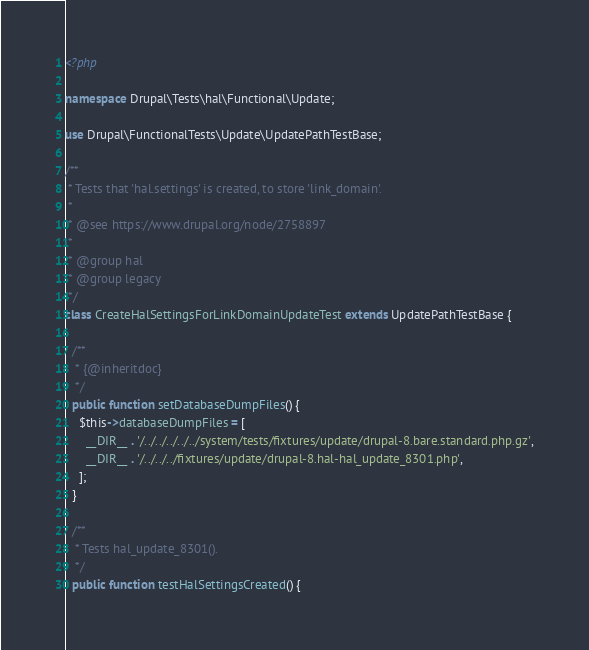<code> <loc_0><loc_0><loc_500><loc_500><_PHP_><?php

namespace Drupal\Tests\hal\Functional\Update;

use Drupal\FunctionalTests\Update\UpdatePathTestBase;

/**
 * Tests that 'hal.settings' is created, to store 'link_domain'.
 *
 * @see https://www.drupal.org/node/2758897
 *
 * @group hal
 * @group legacy
 */
class CreateHalSettingsForLinkDomainUpdateTest extends UpdatePathTestBase {

  /**
   * {@inheritdoc}
   */
  public function setDatabaseDumpFiles() {
    $this->databaseDumpFiles = [
      __DIR__ . '/../../../../../system/tests/fixtures/update/drupal-8.bare.standard.php.gz',
      __DIR__ . '/../../../fixtures/update/drupal-8.hal-hal_update_8301.php',
    ];
  }

  /**
   * Tests hal_update_8301().
   */
  public function testHalSettingsCreated() {</code> 